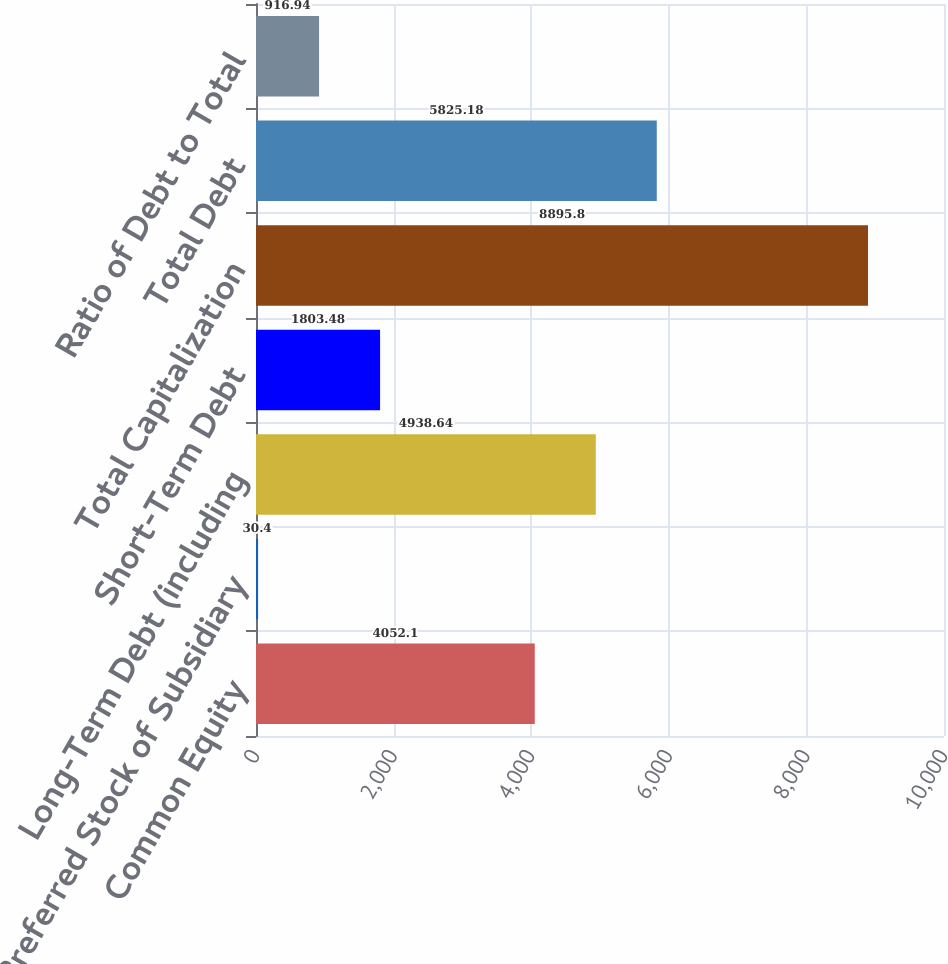Convert chart. <chart><loc_0><loc_0><loc_500><loc_500><bar_chart><fcel>Common Equity<fcel>Preferred Stock of Subsidiary<fcel>Long-Term Debt (including<fcel>Short-Term Debt<fcel>Total Capitalization<fcel>Total Debt<fcel>Ratio of Debt to Total<nl><fcel>4052.1<fcel>30.4<fcel>4938.64<fcel>1803.48<fcel>8895.8<fcel>5825.18<fcel>916.94<nl></chart> 